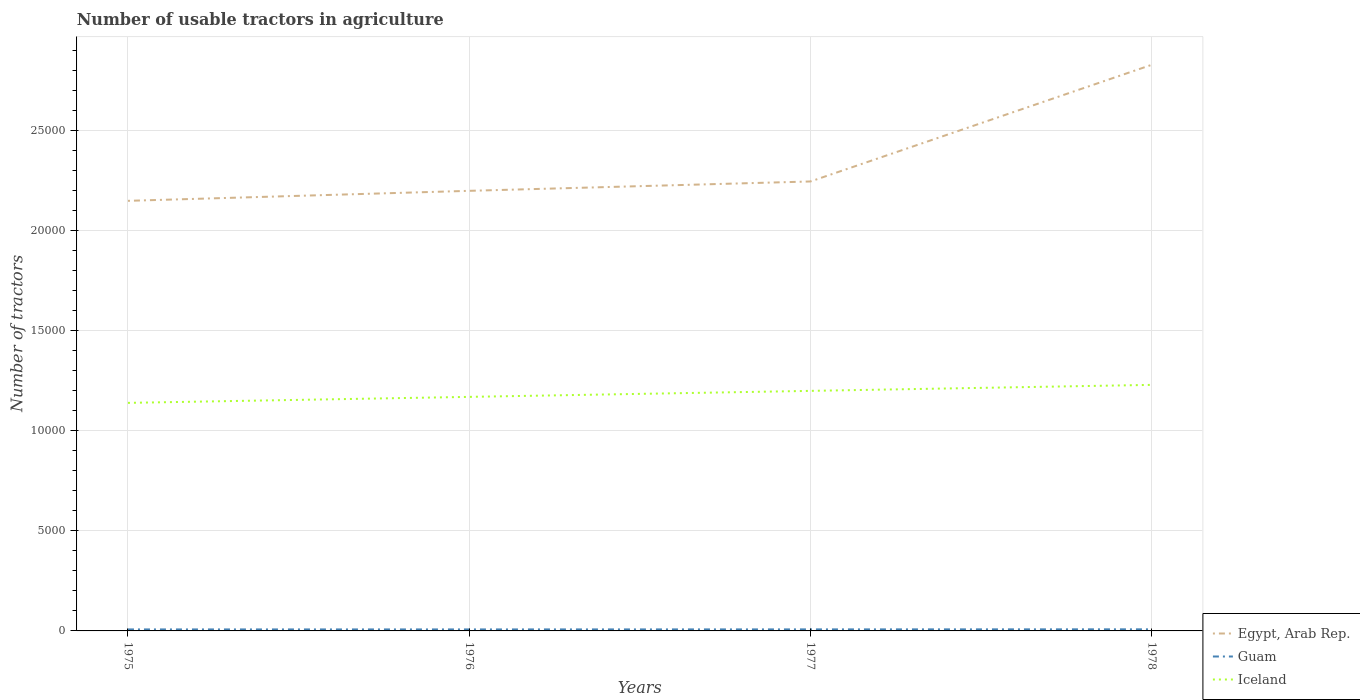How many different coloured lines are there?
Offer a very short reply. 3. Does the line corresponding to Iceland intersect with the line corresponding to Egypt, Arab Rep.?
Make the answer very short. No. Is the number of lines equal to the number of legend labels?
Ensure brevity in your answer.  Yes. In which year was the number of usable tractors in agriculture in Iceland maximum?
Make the answer very short. 1975. What is the total number of usable tractors in agriculture in Egypt, Arab Rep. in the graph?
Provide a succinct answer. -468. What is the difference between the highest and the lowest number of usable tractors in agriculture in Egypt, Arab Rep.?
Ensure brevity in your answer.  1. Is the number of usable tractors in agriculture in Iceland strictly greater than the number of usable tractors in agriculture in Egypt, Arab Rep. over the years?
Provide a short and direct response. Yes. How many lines are there?
Provide a short and direct response. 3. Are the values on the major ticks of Y-axis written in scientific E-notation?
Your answer should be very brief. No. Does the graph contain grids?
Give a very brief answer. Yes. Where does the legend appear in the graph?
Your response must be concise. Bottom right. How many legend labels are there?
Your response must be concise. 3. How are the legend labels stacked?
Offer a terse response. Vertical. What is the title of the graph?
Make the answer very short. Number of usable tractors in agriculture. What is the label or title of the Y-axis?
Give a very brief answer. Number of tractors. What is the Number of tractors in Egypt, Arab Rep. in 1975?
Offer a terse response. 2.15e+04. What is the Number of tractors of Guam in 1975?
Make the answer very short. 75. What is the Number of tractors of Iceland in 1975?
Your answer should be compact. 1.14e+04. What is the Number of tractors of Egypt, Arab Rep. in 1976?
Your response must be concise. 2.20e+04. What is the Number of tractors in Iceland in 1976?
Offer a very short reply. 1.17e+04. What is the Number of tractors in Egypt, Arab Rep. in 1977?
Offer a terse response. 2.25e+04. What is the Number of tractors in Iceland in 1977?
Give a very brief answer. 1.20e+04. What is the Number of tractors in Egypt, Arab Rep. in 1978?
Your response must be concise. 2.83e+04. What is the Number of tractors in Guam in 1978?
Keep it short and to the point. 80. What is the Number of tractors in Iceland in 1978?
Your answer should be compact. 1.23e+04. Across all years, what is the maximum Number of tractors of Egypt, Arab Rep.?
Keep it short and to the point. 2.83e+04. Across all years, what is the maximum Number of tractors in Iceland?
Your answer should be very brief. 1.23e+04. Across all years, what is the minimum Number of tractors of Egypt, Arab Rep.?
Offer a terse response. 2.15e+04. Across all years, what is the minimum Number of tractors of Guam?
Make the answer very short. 75. Across all years, what is the minimum Number of tractors of Iceland?
Ensure brevity in your answer.  1.14e+04. What is the total Number of tractors of Egypt, Arab Rep. in the graph?
Offer a terse response. 9.43e+04. What is the total Number of tractors in Guam in the graph?
Your answer should be very brief. 307. What is the total Number of tractors in Iceland in the graph?
Your answer should be compact. 4.74e+04. What is the difference between the Number of tractors of Egypt, Arab Rep. in 1975 and that in 1976?
Make the answer very short. -500. What is the difference between the Number of tractors of Guam in 1975 and that in 1976?
Your response must be concise. 0. What is the difference between the Number of tractors in Iceland in 1975 and that in 1976?
Offer a terse response. -300. What is the difference between the Number of tractors in Egypt, Arab Rep. in 1975 and that in 1977?
Give a very brief answer. -968. What is the difference between the Number of tractors in Iceland in 1975 and that in 1977?
Keep it short and to the point. -600. What is the difference between the Number of tractors in Egypt, Arab Rep. in 1975 and that in 1978?
Offer a very short reply. -6800. What is the difference between the Number of tractors in Iceland in 1975 and that in 1978?
Keep it short and to the point. -900. What is the difference between the Number of tractors in Egypt, Arab Rep. in 1976 and that in 1977?
Ensure brevity in your answer.  -468. What is the difference between the Number of tractors of Iceland in 1976 and that in 1977?
Give a very brief answer. -300. What is the difference between the Number of tractors in Egypt, Arab Rep. in 1976 and that in 1978?
Your answer should be very brief. -6300. What is the difference between the Number of tractors of Iceland in 1976 and that in 1978?
Ensure brevity in your answer.  -600. What is the difference between the Number of tractors in Egypt, Arab Rep. in 1977 and that in 1978?
Make the answer very short. -5832. What is the difference between the Number of tractors of Guam in 1977 and that in 1978?
Offer a very short reply. -3. What is the difference between the Number of tractors in Iceland in 1977 and that in 1978?
Offer a terse response. -300. What is the difference between the Number of tractors in Egypt, Arab Rep. in 1975 and the Number of tractors in Guam in 1976?
Give a very brief answer. 2.14e+04. What is the difference between the Number of tractors in Egypt, Arab Rep. in 1975 and the Number of tractors in Iceland in 1976?
Offer a terse response. 9800. What is the difference between the Number of tractors in Guam in 1975 and the Number of tractors in Iceland in 1976?
Provide a succinct answer. -1.16e+04. What is the difference between the Number of tractors of Egypt, Arab Rep. in 1975 and the Number of tractors of Guam in 1977?
Your response must be concise. 2.14e+04. What is the difference between the Number of tractors in Egypt, Arab Rep. in 1975 and the Number of tractors in Iceland in 1977?
Keep it short and to the point. 9500. What is the difference between the Number of tractors of Guam in 1975 and the Number of tractors of Iceland in 1977?
Offer a terse response. -1.19e+04. What is the difference between the Number of tractors in Egypt, Arab Rep. in 1975 and the Number of tractors in Guam in 1978?
Your response must be concise. 2.14e+04. What is the difference between the Number of tractors of Egypt, Arab Rep. in 1975 and the Number of tractors of Iceland in 1978?
Give a very brief answer. 9200. What is the difference between the Number of tractors in Guam in 1975 and the Number of tractors in Iceland in 1978?
Provide a succinct answer. -1.22e+04. What is the difference between the Number of tractors in Egypt, Arab Rep. in 1976 and the Number of tractors in Guam in 1977?
Make the answer very short. 2.19e+04. What is the difference between the Number of tractors of Egypt, Arab Rep. in 1976 and the Number of tractors of Iceland in 1977?
Give a very brief answer. 10000. What is the difference between the Number of tractors in Guam in 1976 and the Number of tractors in Iceland in 1977?
Offer a terse response. -1.19e+04. What is the difference between the Number of tractors of Egypt, Arab Rep. in 1976 and the Number of tractors of Guam in 1978?
Give a very brief answer. 2.19e+04. What is the difference between the Number of tractors in Egypt, Arab Rep. in 1976 and the Number of tractors in Iceland in 1978?
Your answer should be compact. 9700. What is the difference between the Number of tractors in Guam in 1976 and the Number of tractors in Iceland in 1978?
Your answer should be very brief. -1.22e+04. What is the difference between the Number of tractors of Egypt, Arab Rep. in 1977 and the Number of tractors of Guam in 1978?
Give a very brief answer. 2.24e+04. What is the difference between the Number of tractors in Egypt, Arab Rep. in 1977 and the Number of tractors in Iceland in 1978?
Provide a short and direct response. 1.02e+04. What is the difference between the Number of tractors in Guam in 1977 and the Number of tractors in Iceland in 1978?
Provide a succinct answer. -1.22e+04. What is the average Number of tractors in Egypt, Arab Rep. per year?
Offer a terse response. 2.36e+04. What is the average Number of tractors of Guam per year?
Offer a terse response. 76.75. What is the average Number of tractors of Iceland per year?
Your answer should be compact. 1.18e+04. In the year 1975, what is the difference between the Number of tractors in Egypt, Arab Rep. and Number of tractors in Guam?
Provide a succinct answer. 2.14e+04. In the year 1975, what is the difference between the Number of tractors of Egypt, Arab Rep. and Number of tractors of Iceland?
Give a very brief answer. 1.01e+04. In the year 1975, what is the difference between the Number of tractors of Guam and Number of tractors of Iceland?
Make the answer very short. -1.13e+04. In the year 1976, what is the difference between the Number of tractors in Egypt, Arab Rep. and Number of tractors in Guam?
Offer a very short reply. 2.19e+04. In the year 1976, what is the difference between the Number of tractors of Egypt, Arab Rep. and Number of tractors of Iceland?
Keep it short and to the point. 1.03e+04. In the year 1976, what is the difference between the Number of tractors of Guam and Number of tractors of Iceland?
Your response must be concise. -1.16e+04. In the year 1977, what is the difference between the Number of tractors in Egypt, Arab Rep. and Number of tractors in Guam?
Keep it short and to the point. 2.24e+04. In the year 1977, what is the difference between the Number of tractors of Egypt, Arab Rep. and Number of tractors of Iceland?
Provide a short and direct response. 1.05e+04. In the year 1977, what is the difference between the Number of tractors of Guam and Number of tractors of Iceland?
Ensure brevity in your answer.  -1.19e+04. In the year 1978, what is the difference between the Number of tractors of Egypt, Arab Rep. and Number of tractors of Guam?
Your response must be concise. 2.82e+04. In the year 1978, what is the difference between the Number of tractors of Egypt, Arab Rep. and Number of tractors of Iceland?
Make the answer very short. 1.60e+04. In the year 1978, what is the difference between the Number of tractors of Guam and Number of tractors of Iceland?
Your response must be concise. -1.22e+04. What is the ratio of the Number of tractors of Egypt, Arab Rep. in 1975 to that in 1976?
Ensure brevity in your answer.  0.98. What is the ratio of the Number of tractors in Iceland in 1975 to that in 1976?
Ensure brevity in your answer.  0.97. What is the ratio of the Number of tractors in Egypt, Arab Rep. in 1975 to that in 1977?
Offer a terse response. 0.96. What is the ratio of the Number of tractors of Guam in 1975 to that in 1977?
Your answer should be compact. 0.97. What is the ratio of the Number of tractors in Iceland in 1975 to that in 1977?
Provide a succinct answer. 0.95. What is the ratio of the Number of tractors in Egypt, Arab Rep. in 1975 to that in 1978?
Give a very brief answer. 0.76. What is the ratio of the Number of tractors in Guam in 1975 to that in 1978?
Keep it short and to the point. 0.94. What is the ratio of the Number of tractors of Iceland in 1975 to that in 1978?
Offer a very short reply. 0.93. What is the ratio of the Number of tractors of Egypt, Arab Rep. in 1976 to that in 1977?
Make the answer very short. 0.98. What is the ratio of the Number of tractors of Iceland in 1976 to that in 1977?
Provide a short and direct response. 0.97. What is the ratio of the Number of tractors in Egypt, Arab Rep. in 1976 to that in 1978?
Offer a terse response. 0.78. What is the ratio of the Number of tractors in Iceland in 1976 to that in 1978?
Offer a very short reply. 0.95. What is the ratio of the Number of tractors of Egypt, Arab Rep. in 1977 to that in 1978?
Make the answer very short. 0.79. What is the ratio of the Number of tractors of Guam in 1977 to that in 1978?
Keep it short and to the point. 0.96. What is the ratio of the Number of tractors of Iceland in 1977 to that in 1978?
Your response must be concise. 0.98. What is the difference between the highest and the second highest Number of tractors of Egypt, Arab Rep.?
Your response must be concise. 5832. What is the difference between the highest and the second highest Number of tractors of Guam?
Give a very brief answer. 3. What is the difference between the highest and the second highest Number of tractors in Iceland?
Your answer should be compact. 300. What is the difference between the highest and the lowest Number of tractors in Egypt, Arab Rep.?
Offer a very short reply. 6800. What is the difference between the highest and the lowest Number of tractors of Guam?
Offer a terse response. 5. What is the difference between the highest and the lowest Number of tractors of Iceland?
Make the answer very short. 900. 